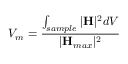<formula> <loc_0><loc_0><loc_500><loc_500>V _ { m } = \frac { \int _ { s a m p l e } | H | ^ { 2 } d V } { | H _ { \max } | ^ { 2 } }</formula> 